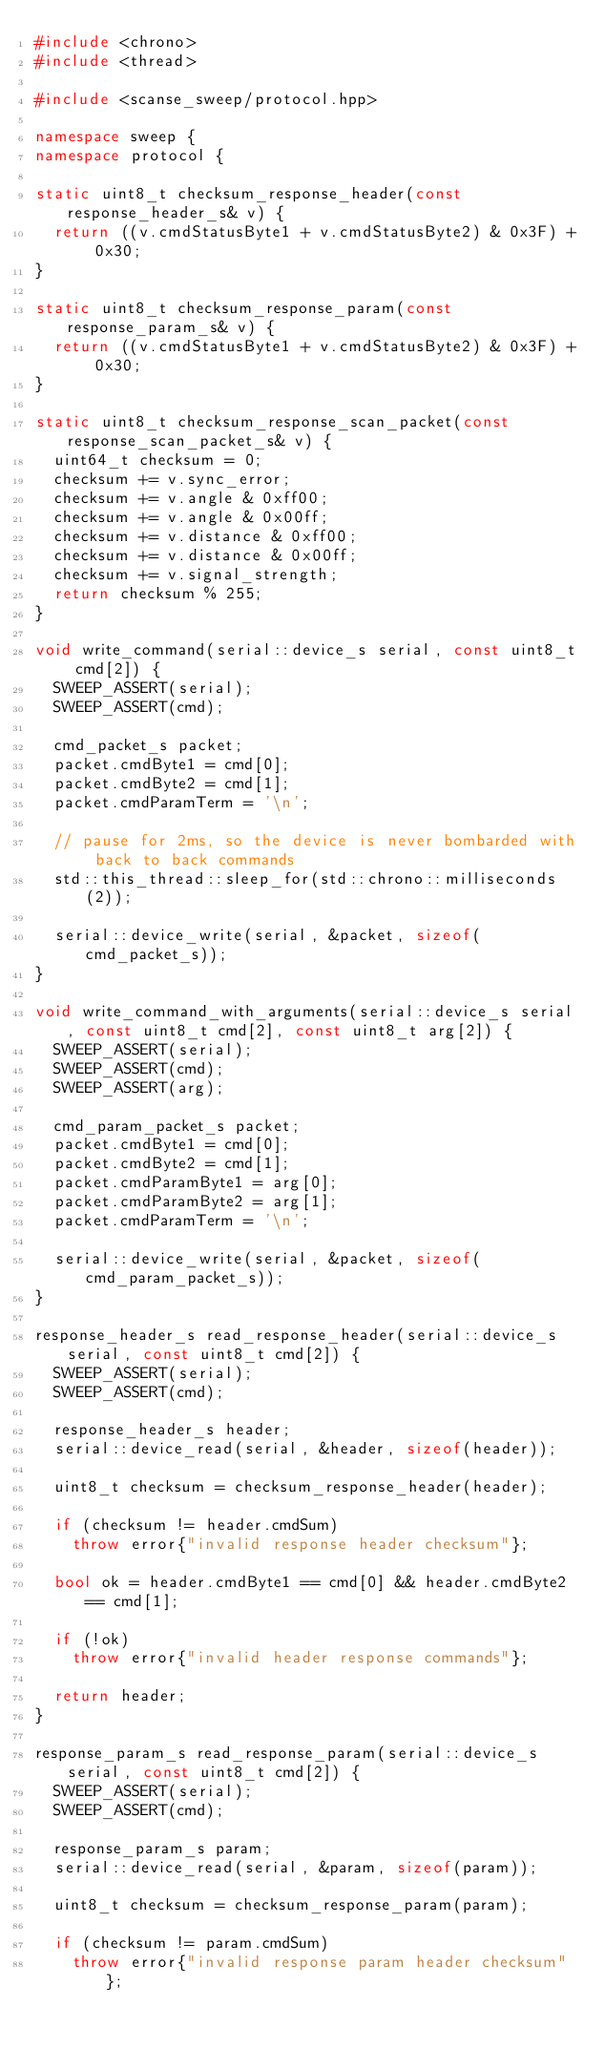Convert code to text. <code><loc_0><loc_0><loc_500><loc_500><_C++_>#include <chrono>
#include <thread>

#include <scanse_sweep/protocol.hpp>

namespace sweep {
namespace protocol {

static uint8_t checksum_response_header(const response_header_s& v) {
  return ((v.cmdStatusByte1 + v.cmdStatusByte2) & 0x3F) + 0x30;
}

static uint8_t checksum_response_param(const response_param_s& v) {
  return ((v.cmdStatusByte1 + v.cmdStatusByte2) & 0x3F) + 0x30;
}

static uint8_t checksum_response_scan_packet(const response_scan_packet_s& v) {
  uint64_t checksum = 0;
  checksum += v.sync_error;
  checksum += v.angle & 0xff00;
  checksum += v.angle & 0x00ff;
  checksum += v.distance & 0xff00;
  checksum += v.distance & 0x00ff;
  checksum += v.signal_strength;
  return checksum % 255;
}

void write_command(serial::device_s serial, const uint8_t cmd[2]) {
  SWEEP_ASSERT(serial);
  SWEEP_ASSERT(cmd);

  cmd_packet_s packet;
  packet.cmdByte1 = cmd[0];
  packet.cmdByte2 = cmd[1];
  packet.cmdParamTerm = '\n';

  // pause for 2ms, so the device is never bombarded with back to back commands
  std::this_thread::sleep_for(std::chrono::milliseconds(2));

  serial::device_write(serial, &packet, sizeof(cmd_packet_s));
}

void write_command_with_arguments(serial::device_s serial, const uint8_t cmd[2], const uint8_t arg[2]) {
  SWEEP_ASSERT(serial);
  SWEEP_ASSERT(cmd);
  SWEEP_ASSERT(arg);

  cmd_param_packet_s packet;
  packet.cmdByte1 = cmd[0];
  packet.cmdByte2 = cmd[1];
  packet.cmdParamByte1 = arg[0];
  packet.cmdParamByte2 = arg[1];
  packet.cmdParamTerm = '\n';

  serial::device_write(serial, &packet, sizeof(cmd_param_packet_s));
}

response_header_s read_response_header(serial::device_s serial, const uint8_t cmd[2]) {
  SWEEP_ASSERT(serial);
  SWEEP_ASSERT(cmd);

  response_header_s header;
  serial::device_read(serial, &header, sizeof(header));

  uint8_t checksum = checksum_response_header(header);

  if (checksum != header.cmdSum)
    throw error{"invalid response header checksum"};

  bool ok = header.cmdByte1 == cmd[0] && header.cmdByte2 == cmd[1];

  if (!ok)
    throw error{"invalid header response commands"};

  return header;
}

response_param_s read_response_param(serial::device_s serial, const uint8_t cmd[2]) {
  SWEEP_ASSERT(serial);
  SWEEP_ASSERT(cmd);

  response_param_s param;
  serial::device_read(serial, &param, sizeof(param));

  uint8_t checksum = checksum_response_param(param);

  if (checksum != param.cmdSum)
    throw error{"invalid response param header checksum"};
</code> 